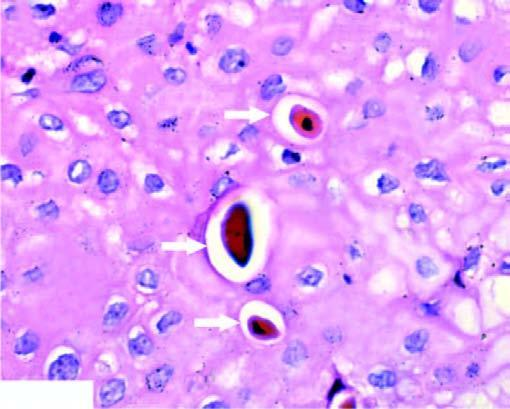has the nucleus clumped chromatin?
Answer the question using a single word or phrase. Yes 